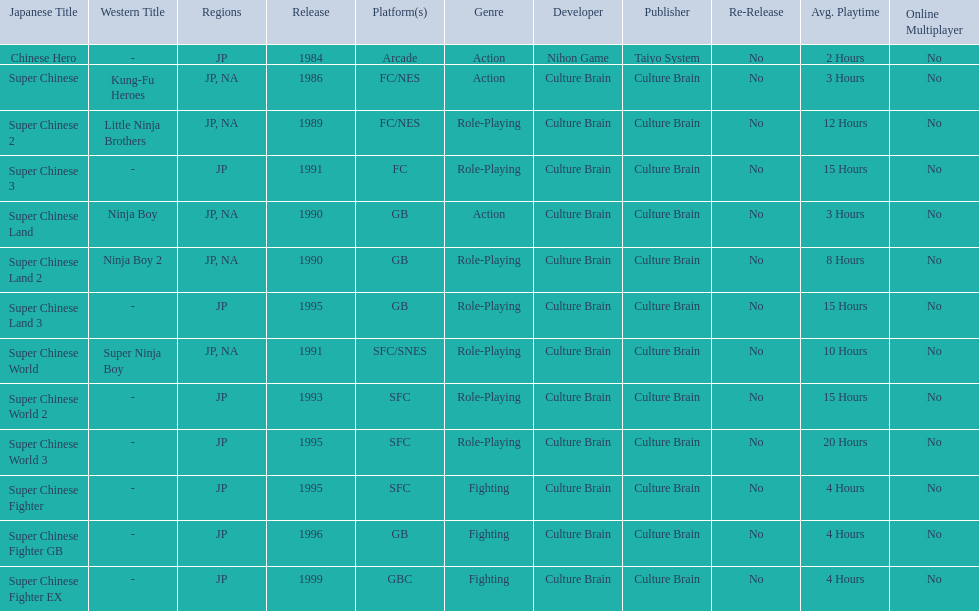What japanese titles were released in the north american (na) region? Super Chinese, Super Chinese 2, Super Chinese Land, Super Chinese Land 2, Super Chinese World. Of those, which one was released most recently? Super Chinese World. 